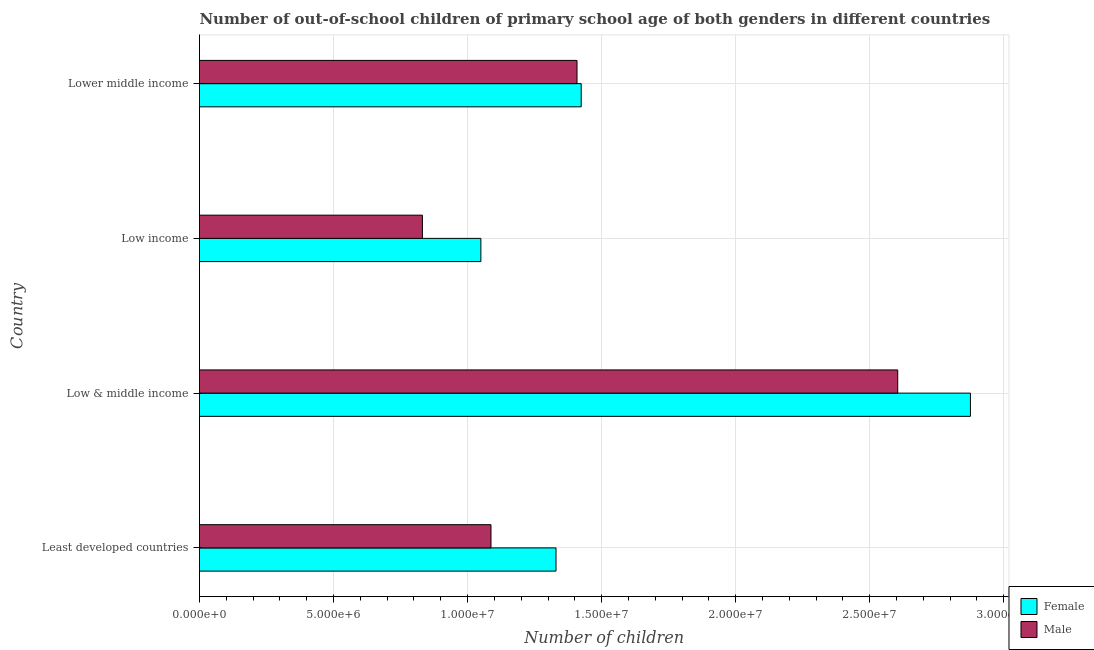How many groups of bars are there?
Make the answer very short. 4. Are the number of bars on each tick of the Y-axis equal?
Offer a very short reply. Yes. How many bars are there on the 3rd tick from the bottom?
Your answer should be very brief. 2. In how many cases, is the number of bars for a given country not equal to the number of legend labels?
Give a very brief answer. 0. What is the number of female out-of-school students in Low income?
Make the answer very short. 1.05e+07. Across all countries, what is the maximum number of male out-of-school students?
Keep it short and to the point. 2.60e+07. Across all countries, what is the minimum number of female out-of-school students?
Provide a succinct answer. 1.05e+07. In which country was the number of female out-of-school students minimum?
Offer a terse response. Low income. What is the total number of male out-of-school students in the graph?
Provide a short and direct response. 5.93e+07. What is the difference between the number of female out-of-school students in Least developed countries and that in Low income?
Give a very brief answer. 2.80e+06. What is the difference between the number of male out-of-school students in Low & middle income and the number of female out-of-school students in Lower middle income?
Your answer should be very brief. 1.18e+07. What is the average number of female out-of-school students per country?
Keep it short and to the point. 1.67e+07. What is the difference between the number of male out-of-school students and number of female out-of-school students in Lower middle income?
Offer a terse response. -1.56e+05. In how many countries, is the number of female out-of-school students greater than 24000000 ?
Provide a short and direct response. 1. What is the ratio of the number of female out-of-school students in Low & middle income to that in Low income?
Offer a terse response. 2.74. Is the difference between the number of female out-of-school students in Least developed countries and Lower middle income greater than the difference between the number of male out-of-school students in Least developed countries and Lower middle income?
Your answer should be compact. Yes. What is the difference between the highest and the second highest number of male out-of-school students?
Provide a short and direct response. 1.20e+07. What is the difference between the highest and the lowest number of female out-of-school students?
Provide a succinct answer. 1.83e+07. Is the sum of the number of female out-of-school students in Least developed countries and Low & middle income greater than the maximum number of male out-of-school students across all countries?
Your answer should be very brief. Yes. Are all the bars in the graph horizontal?
Give a very brief answer. Yes. How many countries are there in the graph?
Ensure brevity in your answer.  4. Does the graph contain any zero values?
Keep it short and to the point. No. Does the graph contain grids?
Keep it short and to the point. Yes. Where does the legend appear in the graph?
Offer a very short reply. Bottom right. How many legend labels are there?
Give a very brief answer. 2. How are the legend labels stacked?
Ensure brevity in your answer.  Vertical. What is the title of the graph?
Offer a very short reply. Number of out-of-school children of primary school age of both genders in different countries. Does "Net National savings" appear as one of the legend labels in the graph?
Make the answer very short. No. What is the label or title of the X-axis?
Ensure brevity in your answer.  Number of children. What is the label or title of the Y-axis?
Make the answer very short. Country. What is the Number of children in Female in Least developed countries?
Make the answer very short. 1.33e+07. What is the Number of children of Male in Least developed countries?
Ensure brevity in your answer.  1.09e+07. What is the Number of children in Female in Low & middle income?
Give a very brief answer. 2.88e+07. What is the Number of children of Male in Low & middle income?
Provide a short and direct response. 2.60e+07. What is the Number of children in Female in Low income?
Offer a terse response. 1.05e+07. What is the Number of children in Male in Low income?
Offer a terse response. 8.32e+06. What is the Number of children of Female in Lower middle income?
Your response must be concise. 1.42e+07. What is the Number of children of Male in Lower middle income?
Provide a succinct answer. 1.41e+07. Across all countries, what is the maximum Number of children in Female?
Ensure brevity in your answer.  2.88e+07. Across all countries, what is the maximum Number of children in Male?
Your response must be concise. 2.60e+07. Across all countries, what is the minimum Number of children of Female?
Offer a terse response. 1.05e+07. Across all countries, what is the minimum Number of children in Male?
Make the answer very short. 8.32e+06. What is the total Number of children in Female in the graph?
Keep it short and to the point. 6.68e+07. What is the total Number of children of Male in the graph?
Provide a succinct answer. 5.93e+07. What is the difference between the Number of children of Female in Least developed countries and that in Low & middle income?
Your response must be concise. -1.55e+07. What is the difference between the Number of children of Male in Least developed countries and that in Low & middle income?
Provide a succinct answer. -1.52e+07. What is the difference between the Number of children in Female in Least developed countries and that in Low income?
Offer a terse response. 2.80e+06. What is the difference between the Number of children in Male in Least developed countries and that in Low income?
Make the answer very short. 2.56e+06. What is the difference between the Number of children of Female in Least developed countries and that in Lower middle income?
Provide a short and direct response. -9.39e+05. What is the difference between the Number of children of Male in Least developed countries and that in Lower middle income?
Your response must be concise. -3.21e+06. What is the difference between the Number of children in Female in Low & middle income and that in Low income?
Your response must be concise. 1.83e+07. What is the difference between the Number of children of Male in Low & middle income and that in Low income?
Offer a very short reply. 1.77e+07. What is the difference between the Number of children of Female in Low & middle income and that in Lower middle income?
Your answer should be compact. 1.45e+07. What is the difference between the Number of children in Male in Low & middle income and that in Lower middle income?
Your response must be concise. 1.20e+07. What is the difference between the Number of children in Female in Low income and that in Lower middle income?
Give a very brief answer. -3.74e+06. What is the difference between the Number of children of Male in Low income and that in Lower middle income?
Offer a very short reply. -5.77e+06. What is the difference between the Number of children in Female in Least developed countries and the Number of children in Male in Low & middle income?
Ensure brevity in your answer.  -1.27e+07. What is the difference between the Number of children of Female in Least developed countries and the Number of children of Male in Low income?
Make the answer very short. 4.98e+06. What is the difference between the Number of children in Female in Least developed countries and the Number of children in Male in Lower middle income?
Your answer should be compact. -7.83e+05. What is the difference between the Number of children in Female in Low & middle income and the Number of children in Male in Low income?
Your response must be concise. 2.04e+07. What is the difference between the Number of children in Female in Low & middle income and the Number of children in Male in Lower middle income?
Offer a very short reply. 1.47e+07. What is the difference between the Number of children of Female in Low income and the Number of children of Male in Lower middle income?
Your answer should be compact. -3.59e+06. What is the average Number of children of Female per country?
Provide a short and direct response. 1.67e+07. What is the average Number of children of Male per country?
Your answer should be compact. 1.48e+07. What is the difference between the Number of children in Female and Number of children in Male in Least developed countries?
Provide a succinct answer. 2.43e+06. What is the difference between the Number of children in Female and Number of children in Male in Low & middle income?
Your answer should be compact. 2.71e+06. What is the difference between the Number of children of Female and Number of children of Male in Low income?
Your answer should be compact. 2.18e+06. What is the difference between the Number of children in Female and Number of children in Male in Lower middle income?
Ensure brevity in your answer.  1.56e+05. What is the ratio of the Number of children in Female in Least developed countries to that in Low & middle income?
Give a very brief answer. 0.46. What is the ratio of the Number of children of Male in Least developed countries to that in Low & middle income?
Offer a terse response. 0.42. What is the ratio of the Number of children in Female in Least developed countries to that in Low income?
Offer a very short reply. 1.27. What is the ratio of the Number of children of Male in Least developed countries to that in Low income?
Your answer should be compact. 1.31. What is the ratio of the Number of children of Female in Least developed countries to that in Lower middle income?
Offer a very short reply. 0.93. What is the ratio of the Number of children in Male in Least developed countries to that in Lower middle income?
Offer a very short reply. 0.77. What is the ratio of the Number of children of Female in Low & middle income to that in Low income?
Your answer should be compact. 2.74. What is the ratio of the Number of children in Male in Low & middle income to that in Low income?
Give a very brief answer. 3.13. What is the ratio of the Number of children in Female in Low & middle income to that in Lower middle income?
Your answer should be compact. 2.02. What is the ratio of the Number of children in Male in Low & middle income to that in Lower middle income?
Offer a very short reply. 1.85. What is the ratio of the Number of children of Female in Low income to that in Lower middle income?
Ensure brevity in your answer.  0.74. What is the ratio of the Number of children in Male in Low income to that in Lower middle income?
Ensure brevity in your answer.  0.59. What is the difference between the highest and the second highest Number of children in Female?
Provide a short and direct response. 1.45e+07. What is the difference between the highest and the second highest Number of children of Male?
Provide a short and direct response. 1.20e+07. What is the difference between the highest and the lowest Number of children of Female?
Keep it short and to the point. 1.83e+07. What is the difference between the highest and the lowest Number of children in Male?
Make the answer very short. 1.77e+07. 